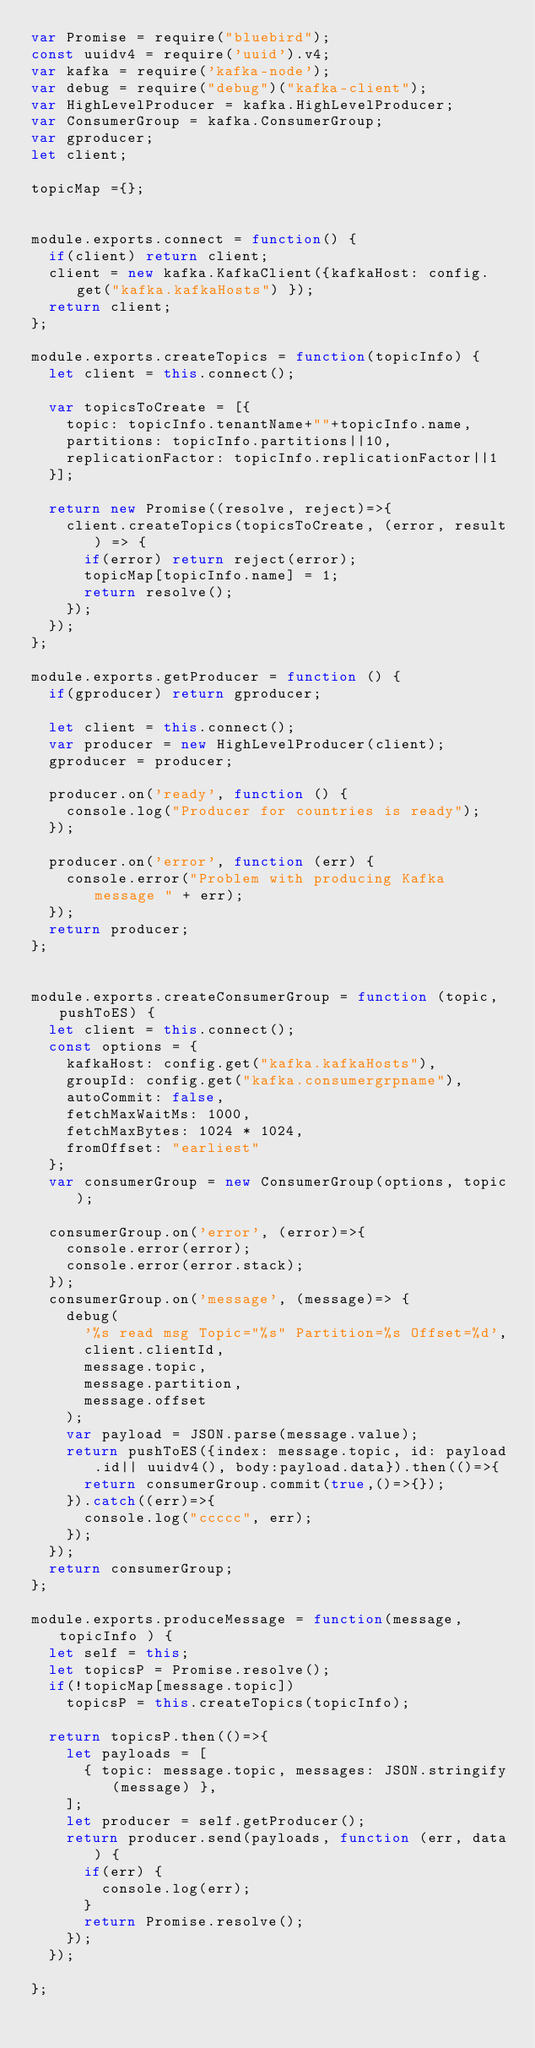Convert code to text. <code><loc_0><loc_0><loc_500><loc_500><_JavaScript_>var Promise = require("bluebird");
const uuidv4 = require('uuid').v4;
var kafka = require('kafka-node');
var debug = require("debug")("kafka-client");
var HighLevelProducer = kafka.HighLevelProducer;
var ConsumerGroup = kafka.ConsumerGroup;
var gproducer;
let client;

topicMap ={};


module.exports.connect = function() {
	if(client) return client;
	client = new kafka.KafkaClient({kafkaHost: config.get("kafka.kafkaHosts") });
	return client;
};

module.exports.createTopics = function(topicInfo) {
	let client = this.connect();

	var topicsToCreate = [{
		topic: topicInfo.tenantName+""+topicInfo.name,
		partitions: topicInfo.partitions||10,
		replicationFactor: topicInfo.replicationFactor||1
	}];

	return new Promise((resolve, reject)=>{
		client.createTopics(topicsToCreate, (error, result) => {
			if(error) return reject(error);
			topicMap[topicInfo.name] = 1;
			return resolve();
		});
	});
};

module.exports.getProducer = function () {
	if(gproducer) return gproducer;

	let client = this.connect();
	var producer = new HighLevelProducer(client);
	gproducer = producer;

	producer.on('ready', function () {
		console.log("Producer for countries is ready");
	});

	producer.on('error', function (err) {
		console.error("Problem with producing Kafka message " + err);
	});
	return producer;
};


module.exports.createConsumerGroup = function (topic, pushToES) {
	let client = this.connect();
	const options = {
		kafkaHost: config.get("kafka.kafkaHosts"),
		groupId: config.get("kafka.consumergrpname"),
		autoCommit: false,
		fetchMaxWaitMs: 1000,
		fetchMaxBytes: 1024 * 1024,
		fromOffset: "earliest"
	};
	var consumerGroup = new ConsumerGroup(options, topic);

	consumerGroup.on('error', (error)=>{
		console.error(error);
		console.error(error.stack);
	});
	consumerGroup.on('message', (message)=> {
		debug(
			'%s read msg Topic="%s" Partition=%s Offset=%d',
			client.clientId,
			message.topic,
			message.partition,
			message.offset
		);
		var payload = JSON.parse(message.value);
		return pushToES({index: message.topic, id: payload.id|| uuidv4(), body:payload.data}).then(()=>{
			return consumerGroup.commit(true,()=>{});
		}).catch((err)=>{
			console.log("ccccc", err);
		});
	});
	return consumerGroup;
};

module.exports.produceMessage = function(message, topicInfo ) {
	let self = this;
	let topicsP = Promise.resolve();
	if(!topicMap[message.topic])
		topicsP = this.createTopics(topicInfo);
    
	return topicsP.then(()=>{
		let payloads = [
			{ topic: message.topic, messages: JSON.stringify(message) },
		];
		let producer = self.getProducer();
		return producer.send(payloads, function (err, data) {
			if(err) {
				console.log(err);
			}
			return Promise.resolve();
		});
	});
    
};
</code> 